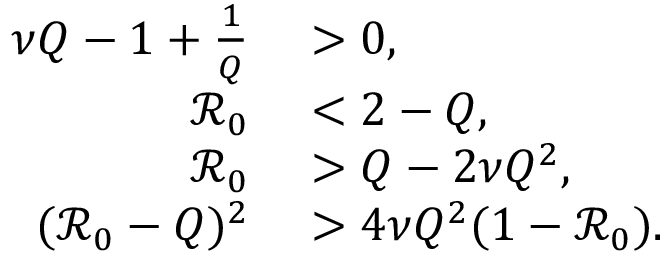<formula> <loc_0><loc_0><loc_500><loc_500>\begin{array} { r l } { \nu Q - 1 + \frac { 1 } { Q } } & > 0 , } \\ { \mathcal { R } _ { 0 } } & < 2 - Q , } \\ { \mathcal { R } _ { 0 } } & > Q - 2 \nu Q ^ { 2 } , } \\ { ( \mathcal { R } _ { 0 } - Q ) ^ { 2 } } & > 4 \nu Q ^ { 2 } ( 1 - \mathcal { R } _ { 0 } ) . } \end{array}</formula> 